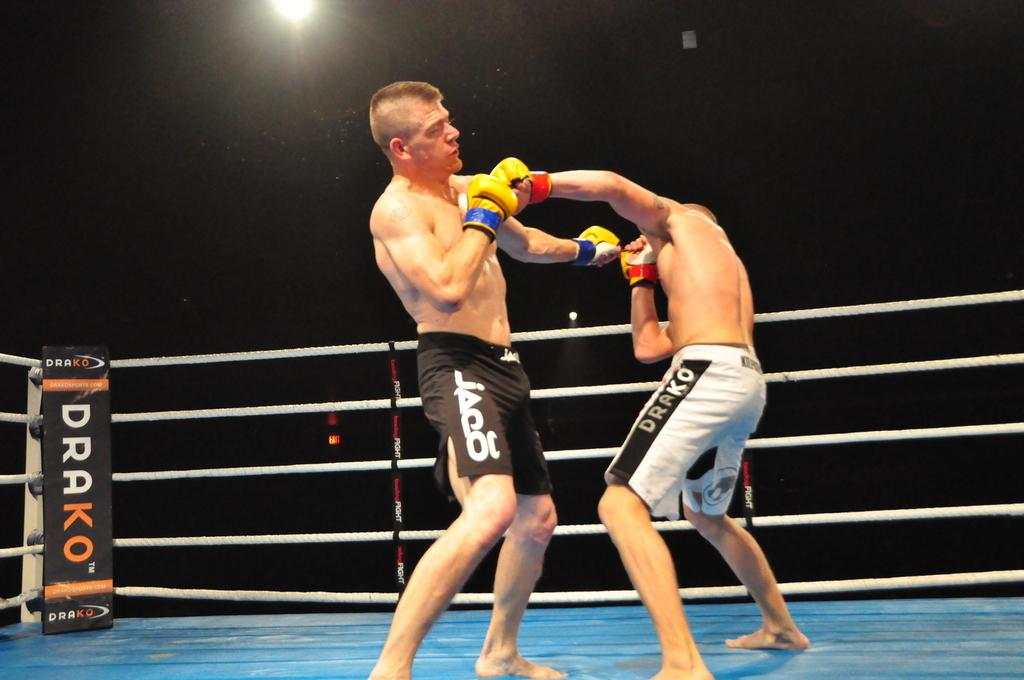<image>
Describe the image concisely. Two mma fighters are in the middle of the ring with the logo for drako on the corner of the ring. 